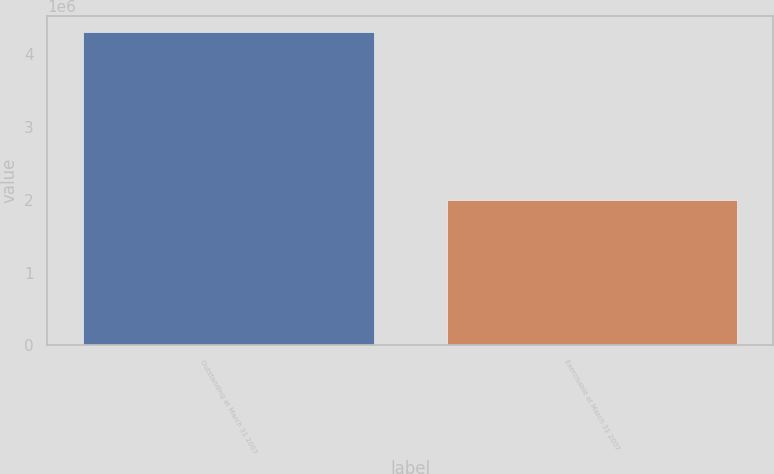<chart> <loc_0><loc_0><loc_500><loc_500><bar_chart><fcel>Outstanding at March 31 2007<fcel>Exercisable at March 31 2007<nl><fcel>4.30592e+06<fcel>1.99701e+06<nl></chart> 